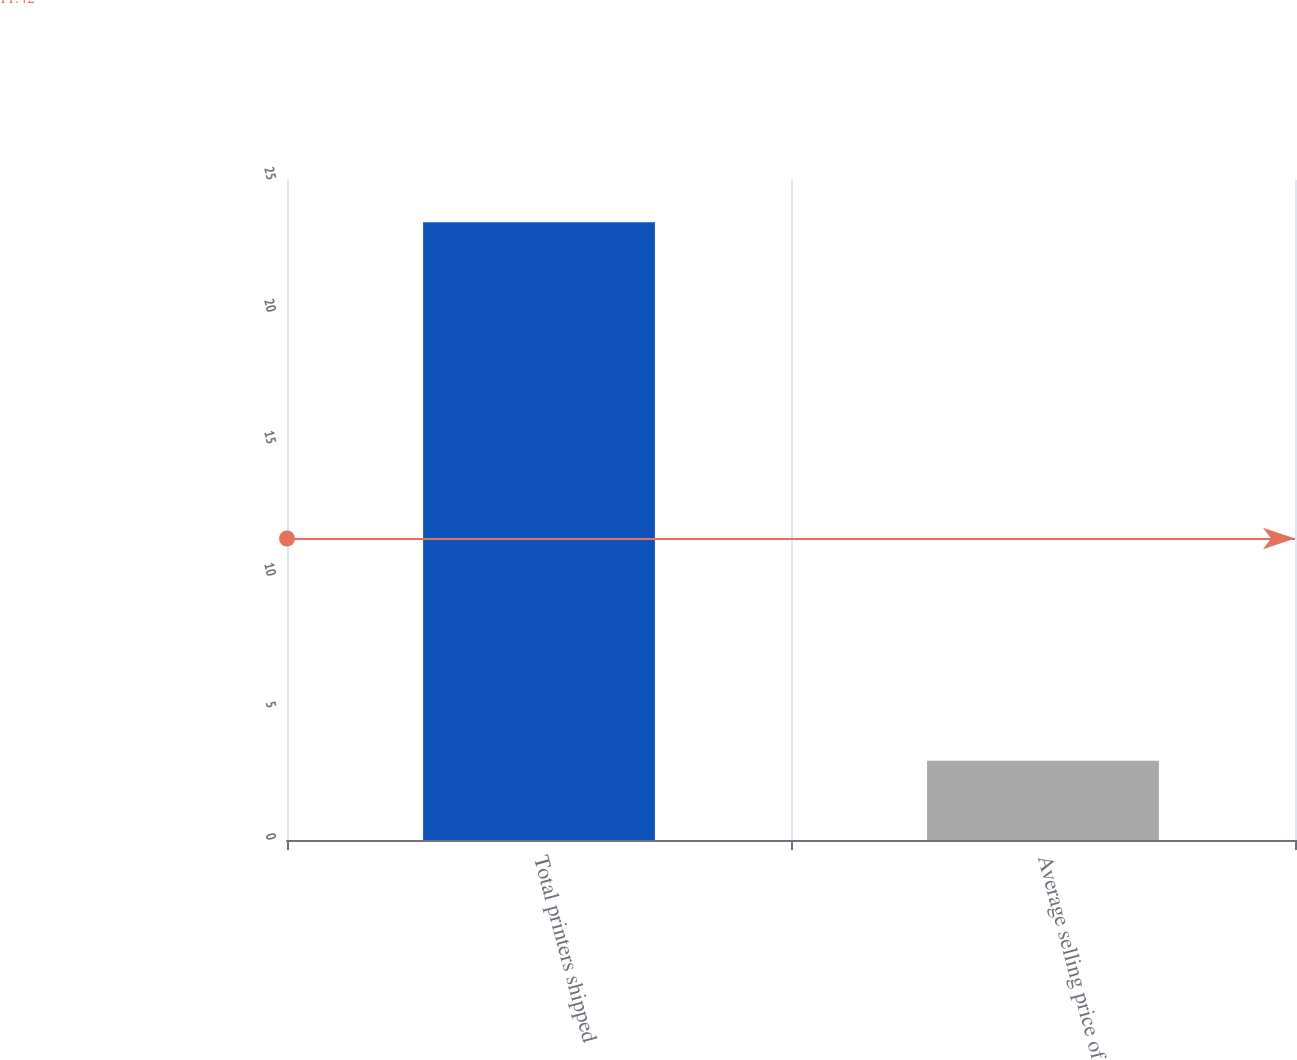Convert chart to OTSL. <chart><loc_0><loc_0><loc_500><loc_500><bar_chart><fcel>Total printers shipped<fcel>Average selling price of<nl><fcel>23.4<fcel>3<nl></chart> 